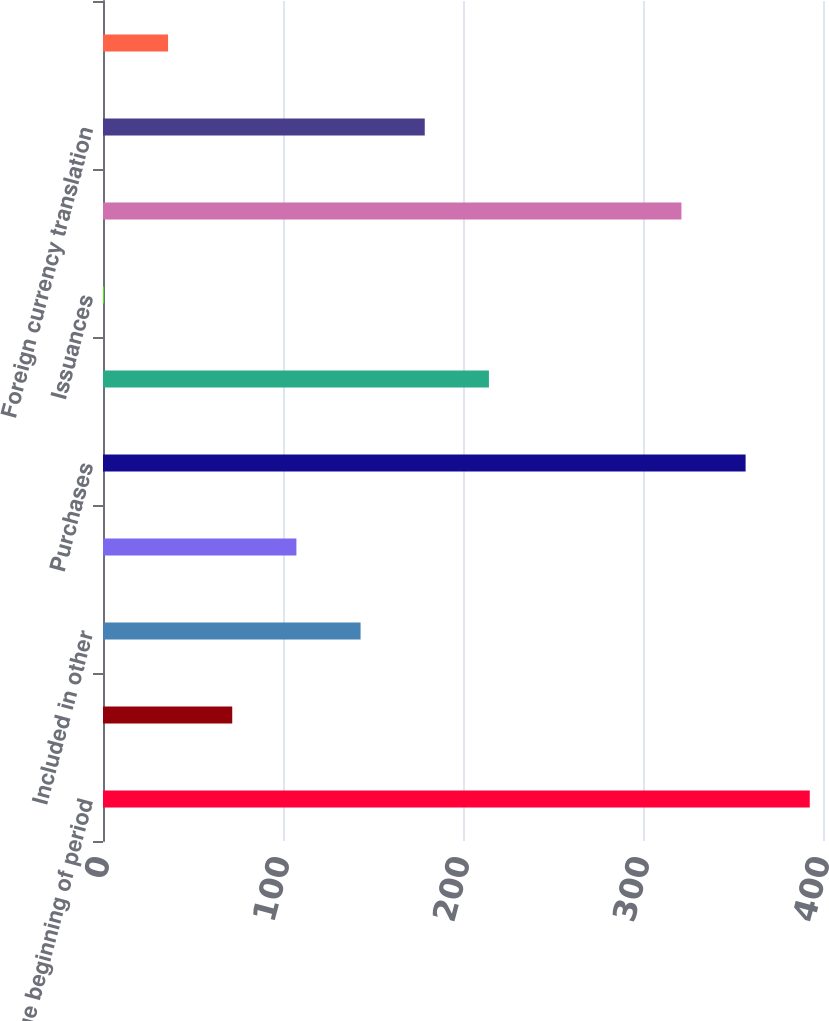Convert chart. <chart><loc_0><loc_0><loc_500><loc_500><bar_chart><fcel>Fair Value beginning of period<fcel>Realized investment gains<fcel>Included in other<fcel>Net investment income<fcel>Purchases<fcel>Sales<fcel>Issuances<fcel>Settlements<fcel>Foreign currency translation<fcel>Other(1)<nl><fcel>392.65<fcel>71.8<fcel>143.1<fcel>107.45<fcel>357<fcel>214.4<fcel>0.5<fcel>321.35<fcel>178.75<fcel>36.15<nl></chart> 